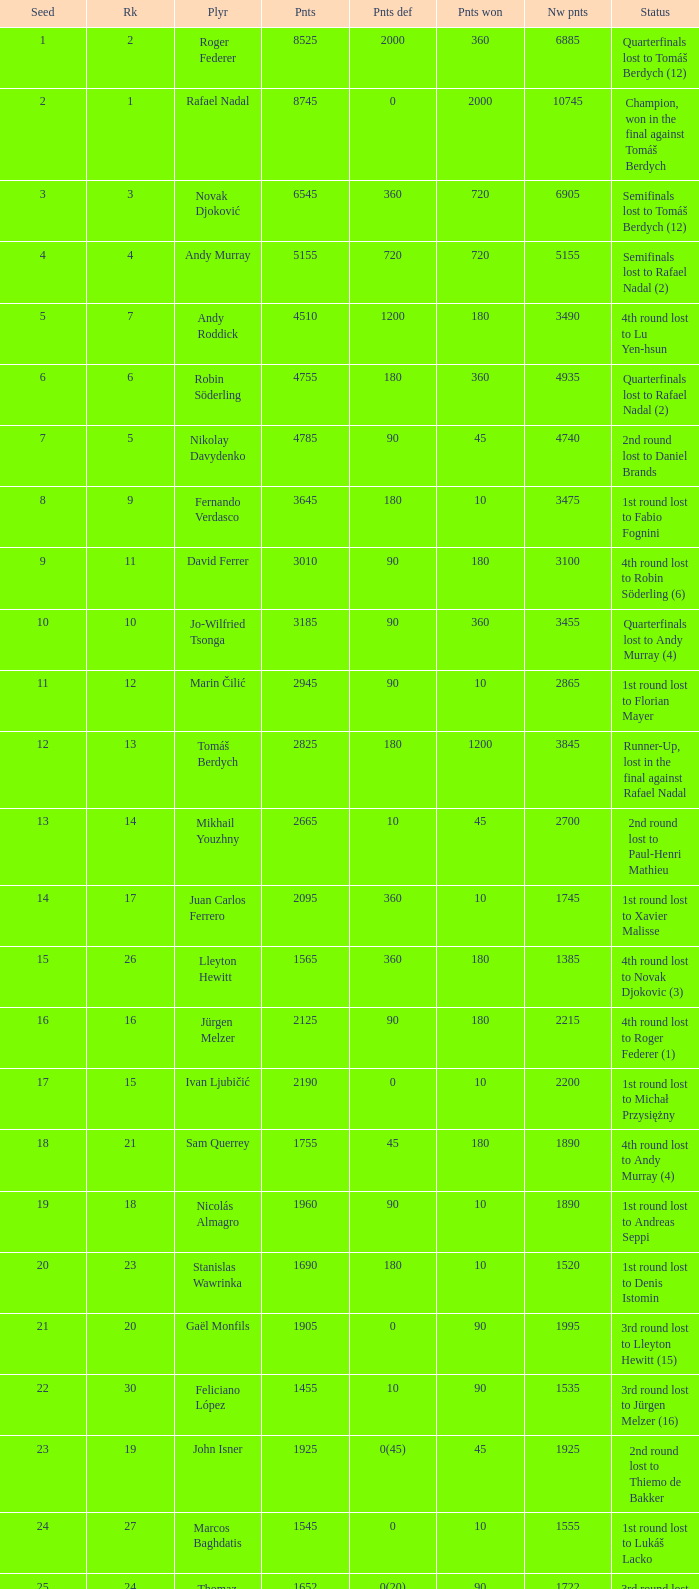Name the least new points for points defending is 1200 3490.0. Would you be able to parse every entry in this table? {'header': ['Seed', 'Rk', 'Plyr', 'Pnts', 'Pnts def', 'Pnts won', 'Nw pnts', 'Status'], 'rows': [['1', '2', 'Roger Federer', '8525', '2000', '360', '6885', 'Quarterfinals lost to Tomáš Berdych (12)'], ['2', '1', 'Rafael Nadal', '8745', '0', '2000', '10745', 'Champion, won in the final against Tomáš Berdych'], ['3', '3', 'Novak Djoković', '6545', '360', '720', '6905', 'Semifinals lost to Tomáš Berdych (12)'], ['4', '4', 'Andy Murray', '5155', '720', '720', '5155', 'Semifinals lost to Rafael Nadal (2)'], ['5', '7', 'Andy Roddick', '4510', '1200', '180', '3490', '4th round lost to Lu Yen-hsun'], ['6', '6', 'Robin Söderling', '4755', '180', '360', '4935', 'Quarterfinals lost to Rafael Nadal (2)'], ['7', '5', 'Nikolay Davydenko', '4785', '90', '45', '4740', '2nd round lost to Daniel Brands'], ['8', '9', 'Fernando Verdasco', '3645', '180', '10', '3475', '1st round lost to Fabio Fognini'], ['9', '11', 'David Ferrer', '3010', '90', '180', '3100', '4th round lost to Robin Söderling (6)'], ['10', '10', 'Jo-Wilfried Tsonga', '3185', '90', '360', '3455', 'Quarterfinals lost to Andy Murray (4)'], ['11', '12', 'Marin Čilić', '2945', '90', '10', '2865', '1st round lost to Florian Mayer'], ['12', '13', 'Tomáš Berdych', '2825', '180', '1200', '3845', 'Runner-Up, lost in the final against Rafael Nadal'], ['13', '14', 'Mikhail Youzhny', '2665', '10', '45', '2700', '2nd round lost to Paul-Henri Mathieu'], ['14', '17', 'Juan Carlos Ferrero', '2095', '360', '10', '1745', '1st round lost to Xavier Malisse'], ['15', '26', 'Lleyton Hewitt', '1565', '360', '180', '1385', '4th round lost to Novak Djokovic (3)'], ['16', '16', 'Jürgen Melzer', '2125', '90', '180', '2215', '4th round lost to Roger Federer (1)'], ['17', '15', 'Ivan Ljubičić', '2190', '0', '10', '2200', '1st round lost to Michał Przysiężny'], ['18', '21', 'Sam Querrey', '1755', '45', '180', '1890', '4th round lost to Andy Murray (4)'], ['19', '18', 'Nicolás Almagro', '1960', '90', '10', '1890', '1st round lost to Andreas Seppi'], ['20', '23', 'Stanislas Wawrinka', '1690', '180', '10', '1520', '1st round lost to Denis Istomin'], ['21', '20', 'Gaël Monfils', '1905', '0', '90', '1995', '3rd round lost to Lleyton Hewitt (15)'], ['22', '30', 'Feliciano López', '1455', '10', '90', '1535', '3rd round lost to Jürgen Melzer (16)'], ['23', '19', 'John Isner', '1925', '0(45)', '45', '1925', '2nd round lost to Thiemo de Bakker'], ['24', '27', 'Marcos Baghdatis', '1545', '0', '10', '1555', '1st round lost to Lukáš Lacko'], ['25', '24', 'Thomaz Bellucci', '1652', '0(20)', '90', '1722', '3rd round lost to Robin Söderling (6)'], ['26', '32', 'Gilles Simon', '1305', '180', '90', '1215', '3rd round lost to Andy Murray (4)'], ['28', '31', 'Albert Montañés', '1405', '90', '90', '1405', '3rd round lost to Novak Djokovic (3)'], ['29', '35', 'Philipp Kohlschreiber', '1230', '90', '90', '1230', '3rd round lost to Andy Roddick (5)'], ['30', '36', 'Tommy Robredo', '1155', '90', '10', '1075', '1st round lost to Peter Luczak'], ['31', '37', 'Victor Hănescu', '1070', '45', '90', '1115', '3rd round lost to Daniel Brands'], ['32', '38', 'Julien Benneteau', '1059', '10', '180', '1229', '4th round lost to Jo-Wilfried Tsonga (10)']]} 